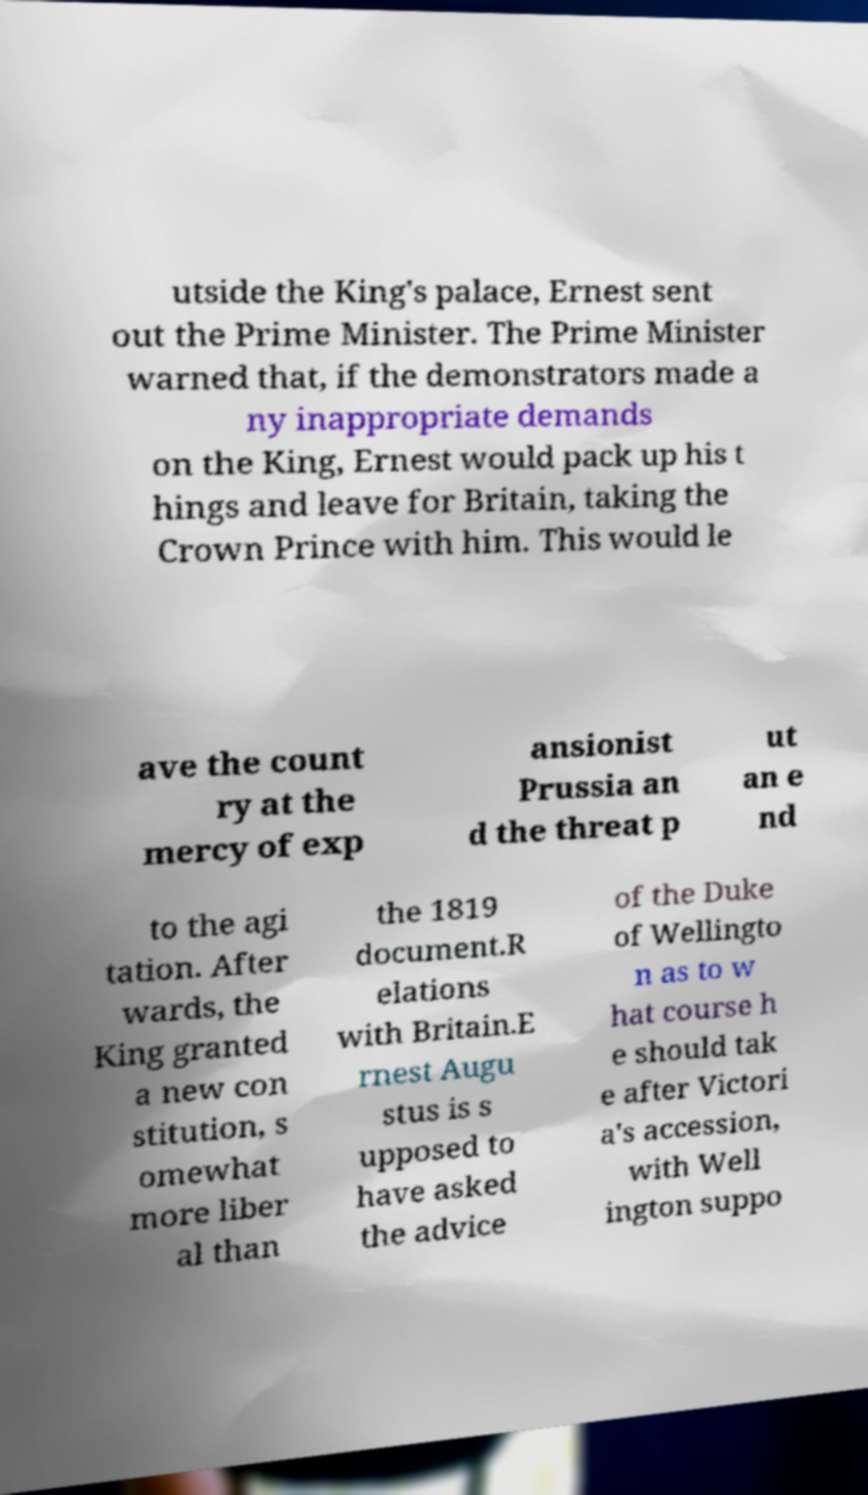Can you accurately transcribe the text from the provided image for me? utside the King's palace, Ernest sent out the Prime Minister. The Prime Minister warned that, if the demonstrators made a ny inappropriate demands on the King, Ernest would pack up his t hings and leave for Britain, taking the Crown Prince with him. This would le ave the count ry at the mercy of exp ansionist Prussia an d the threat p ut an e nd to the agi tation. After wards, the King granted a new con stitution, s omewhat more liber al than the 1819 document.R elations with Britain.E rnest Augu stus is s upposed to have asked the advice of the Duke of Wellingto n as to w hat course h e should tak e after Victori a's accession, with Well ington suppo 